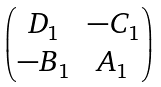<formula> <loc_0><loc_0><loc_500><loc_500>\begin{pmatrix} D _ { 1 } & - C _ { 1 } \\ - B _ { 1 } & A _ { 1 } \end{pmatrix}</formula> 